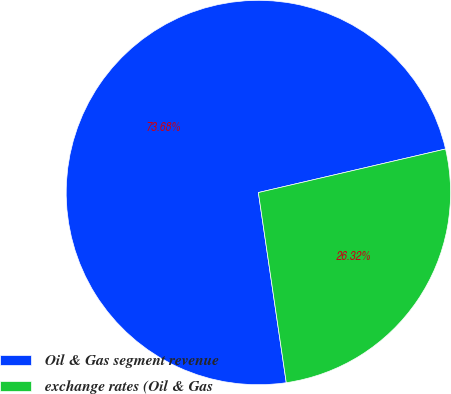Convert chart to OTSL. <chart><loc_0><loc_0><loc_500><loc_500><pie_chart><fcel>Oil & Gas segment revenue<fcel>exchange rates (Oil & Gas<nl><fcel>73.68%<fcel>26.32%<nl></chart> 